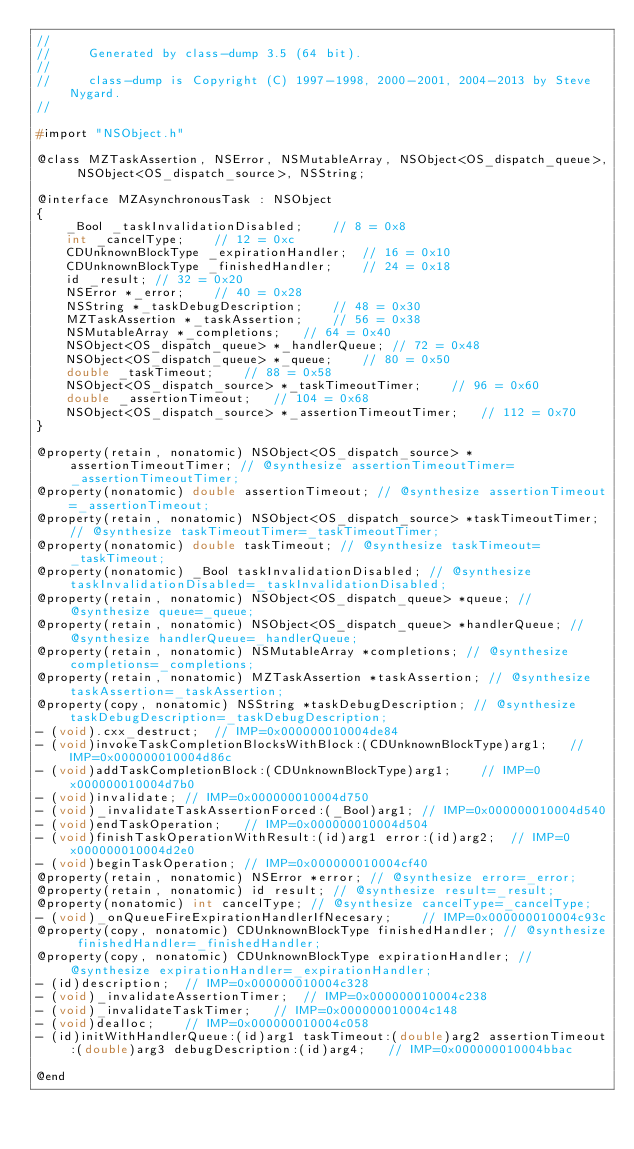Convert code to text. <code><loc_0><loc_0><loc_500><loc_500><_C_>//
//     Generated by class-dump 3.5 (64 bit).
//
//     class-dump is Copyright (C) 1997-1998, 2000-2001, 2004-2013 by Steve Nygard.
//

#import "NSObject.h"

@class MZTaskAssertion, NSError, NSMutableArray, NSObject<OS_dispatch_queue>, NSObject<OS_dispatch_source>, NSString;

@interface MZAsynchronousTask : NSObject
{
    _Bool _taskInvalidationDisabled;	// 8 = 0x8
    int _cancelType;	// 12 = 0xc
    CDUnknownBlockType _expirationHandler;	// 16 = 0x10
    CDUnknownBlockType _finishedHandler;	// 24 = 0x18
    id _result;	// 32 = 0x20
    NSError *_error;	// 40 = 0x28
    NSString *_taskDebugDescription;	// 48 = 0x30
    MZTaskAssertion *_taskAssertion;	// 56 = 0x38
    NSMutableArray *_completions;	// 64 = 0x40
    NSObject<OS_dispatch_queue> *_handlerQueue;	// 72 = 0x48
    NSObject<OS_dispatch_queue> *_queue;	// 80 = 0x50
    double _taskTimeout;	// 88 = 0x58
    NSObject<OS_dispatch_source> *_taskTimeoutTimer;	// 96 = 0x60
    double _assertionTimeout;	// 104 = 0x68
    NSObject<OS_dispatch_source> *_assertionTimeoutTimer;	// 112 = 0x70
}

@property(retain, nonatomic) NSObject<OS_dispatch_source> *assertionTimeoutTimer; // @synthesize assertionTimeoutTimer=_assertionTimeoutTimer;
@property(nonatomic) double assertionTimeout; // @synthesize assertionTimeout=_assertionTimeout;
@property(retain, nonatomic) NSObject<OS_dispatch_source> *taskTimeoutTimer; // @synthesize taskTimeoutTimer=_taskTimeoutTimer;
@property(nonatomic) double taskTimeout; // @synthesize taskTimeout=_taskTimeout;
@property(nonatomic) _Bool taskInvalidationDisabled; // @synthesize taskInvalidationDisabled=_taskInvalidationDisabled;
@property(retain, nonatomic) NSObject<OS_dispatch_queue> *queue; // @synthesize queue=_queue;
@property(retain, nonatomic) NSObject<OS_dispatch_queue> *handlerQueue; // @synthesize handlerQueue=_handlerQueue;
@property(retain, nonatomic) NSMutableArray *completions; // @synthesize completions=_completions;
@property(retain, nonatomic) MZTaskAssertion *taskAssertion; // @synthesize taskAssertion=_taskAssertion;
@property(copy, nonatomic) NSString *taskDebugDescription; // @synthesize taskDebugDescription=_taskDebugDescription;
- (void).cxx_destruct;	// IMP=0x000000010004de84
- (void)invokeTaskCompletionBlocksWithBlock:(CDUnknownBlockType)arg1;	// IMP=0x000000010004d86c
- (void)addTaskCompletionBlock:(CDUnknownBlockType)arg1;	// IMP=0x000000010004d7b0
- (void)invalidate;	// IMP=0x000000010004d750
- (void)_invalidateTaskAssertionForced:(_Bool)arg1;	// IMP=0x000000010004d540
- (void)endTaskOperation;	// IMP=0x000000010004d504
- (void)finishTaskOperationWithResult:(id)arg1 error:(id)arg2;	// IMP=0x000000010004d2e0
- (void)beginTaskOperation;	// IMP=0x000000010004cf40
@property(retain, nonatomic) NSError *error; // @synthesize error=_error;
@property(retain, nonatomic) id result; // @synthesize result=_result;
@property(nonatomic) int cancelType; // @synthesize cancelType=_cancelType;
- (void)_onQueueFireExpirationHandlerIfNecesary;	// IMP=0x000000010004c93c
@property(copy, nonatomic) CDUnknownBlockType finishedHandler; // @synthesize finishedHandler=_finishedHandler;
@property(copy, nonatomic) CDUnknownBlockType expirationHandler; // @synthesize expirationHandler=_expirationHandler;
- (id)description;	// IMP=0x000000010004c328
- (void)_invalidateAssertionTimer;	// IMP=0x000000010004c238
- (void)_invalidateTaskTimer;	// IMP=0x000000010004c148
- (void)dealloc;	// IMP=0x000000010004c058
- (id)initWithHandlerQueue:(id)arg1 taskTimeout:(double)arg2 assertionTimeout:(double)arg3 debugDescription:(id)arg4;	// IMP=0x000000010004bbac

@end

</code> 